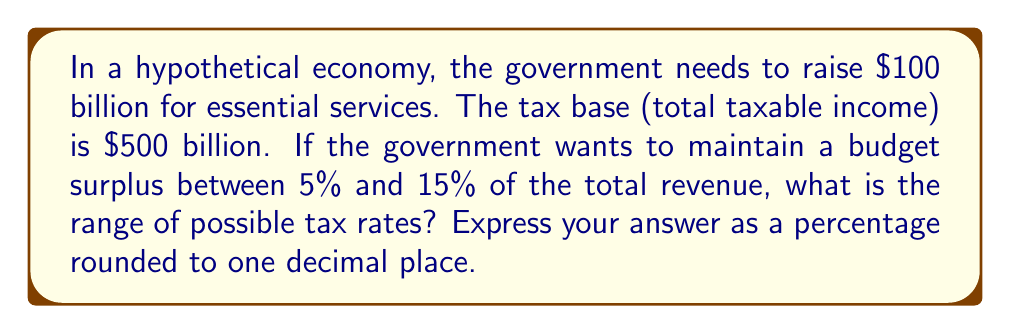Show me your answer to this math problem. Let's approach this step-by-step:

1) Let $x$ be the tax rate as a decimal.

2) The total revenue will be $500 billion * x$.

3) The government needs to raise at least $100 billion, plus 5% to 15% more for the surplus.

4) We can set up two inequalities:

   $500x \geq 100 * 1.05$ (lower bound)
   $500x \leq 100 * 1.15$ (upper bound)

5) Solving the lower bound:
   $500x \geq 105$
   $x \geq 0.21$

6) Solving the upper bound:
   $500x \leq 115$
   $x \leq 0.23$

7) Therefore, $0.21 \leq x \leq 0.23$

8) Converting to percentages and rounding to one decimal place:
   $21.0\% \leq x \leq 23.0\%$
Answer: $21.0\%$ to $23.0\%$ 